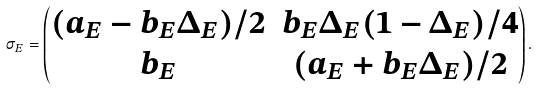Convert formula to latex. <formula><loc_0><loc_0><loc_500><loc_500>\sigma _ { E } = \left ( \begin{matrix} ( a _ { E } - b _ { E } \Delta _ { E } ) / 2 & b _ { E } \Delta _ { E } ( 1 - \Delta _ { E } ) / 4 \\ b _ { E } & ( a _ { E } + b _ { E } \Delta _ { E } ) / 2 \\ \end{matrix} \right ) .</formula> 